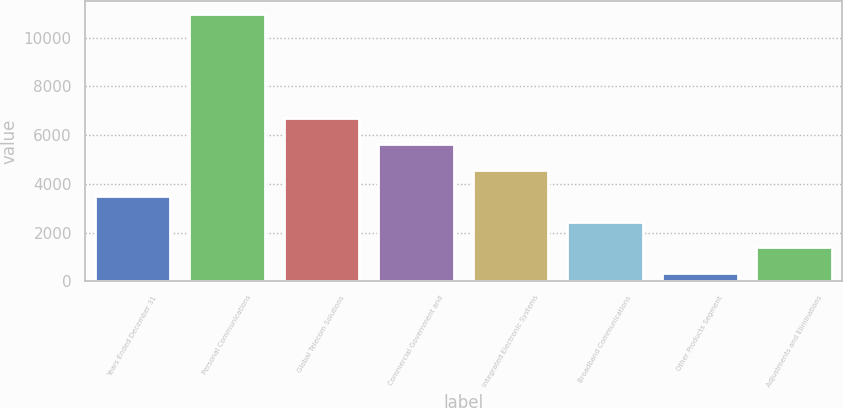Convert chart to OTSL. <chart><loc_0><loc_0><loc_500><loc_500><bar_chart><fcel>Years Ended December 31<fcel>Personal Communications<fcel>Global Telecom Solutions<fcel>Commercial Government and<fcel>Integrated Electronic Systems<fcel>Broadband Communications<fcel>Other Products Segment<fcel>Adjustments and Eliminations<nl><fcel>3519.5<fcel>10978<fcel>6716<fcel>5650.5<fcel>4585<fcel>2454<fcel>323<fcel>1388.5<nl></chart> 